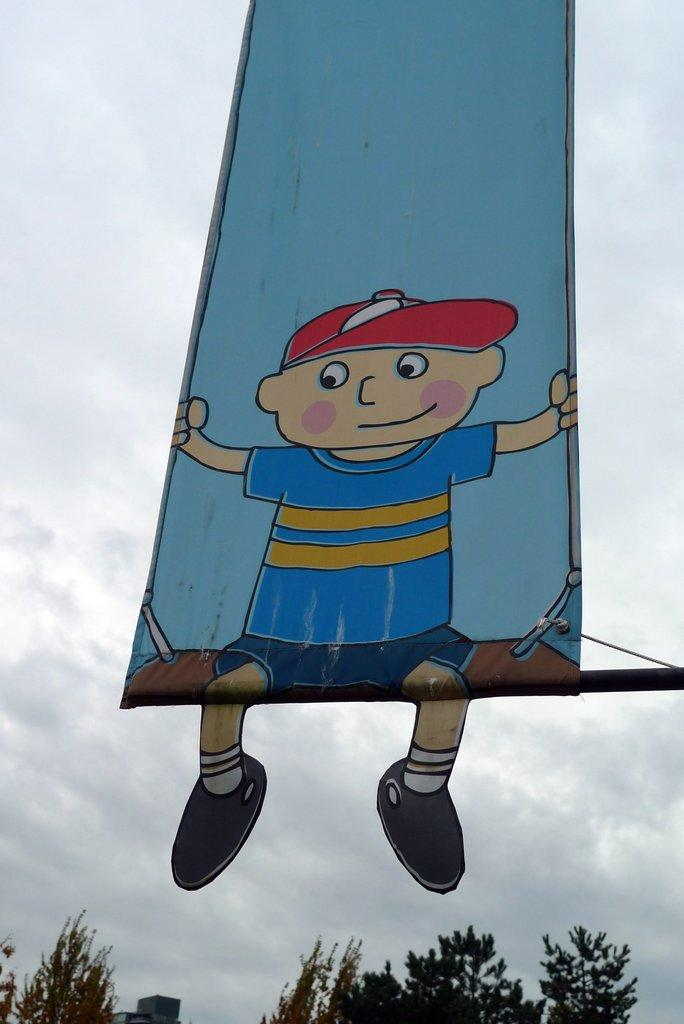What is located at the front of the image? There is a banner in the front of the image. What can be seen in the background of the image? There are trees and a building in the background of the image. What is the condition of the sky in the image? The sky is cloudy in the image. Are there any boats visible in the image? No, there are no boats present in the image. What type of work is being done in the image? There is no indication of any work being done in the image; it primarily features a banner, trees, a building, and a cloudy sky. 